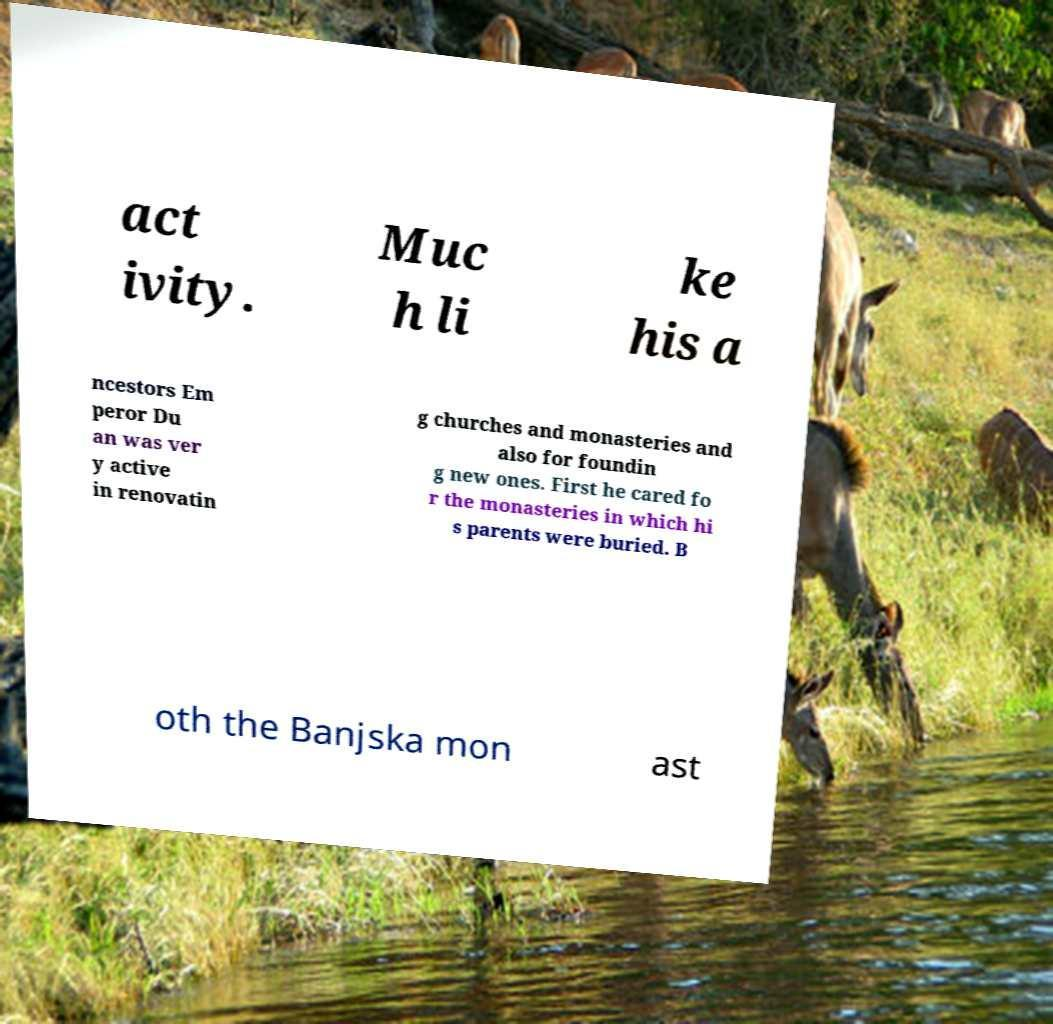Can you read and provide the text displayed in the image?This photo seems to have some interesting text. Can you extract and type it out for me? act ivity. Muc h li ke his a ncestors Em peror Du an was ver y active in renovatin g churches and monasteries and also for foundin g new ones. First he cared fo r the monasteries in which hi s parents were buried. B oth the Banjska mon ast 